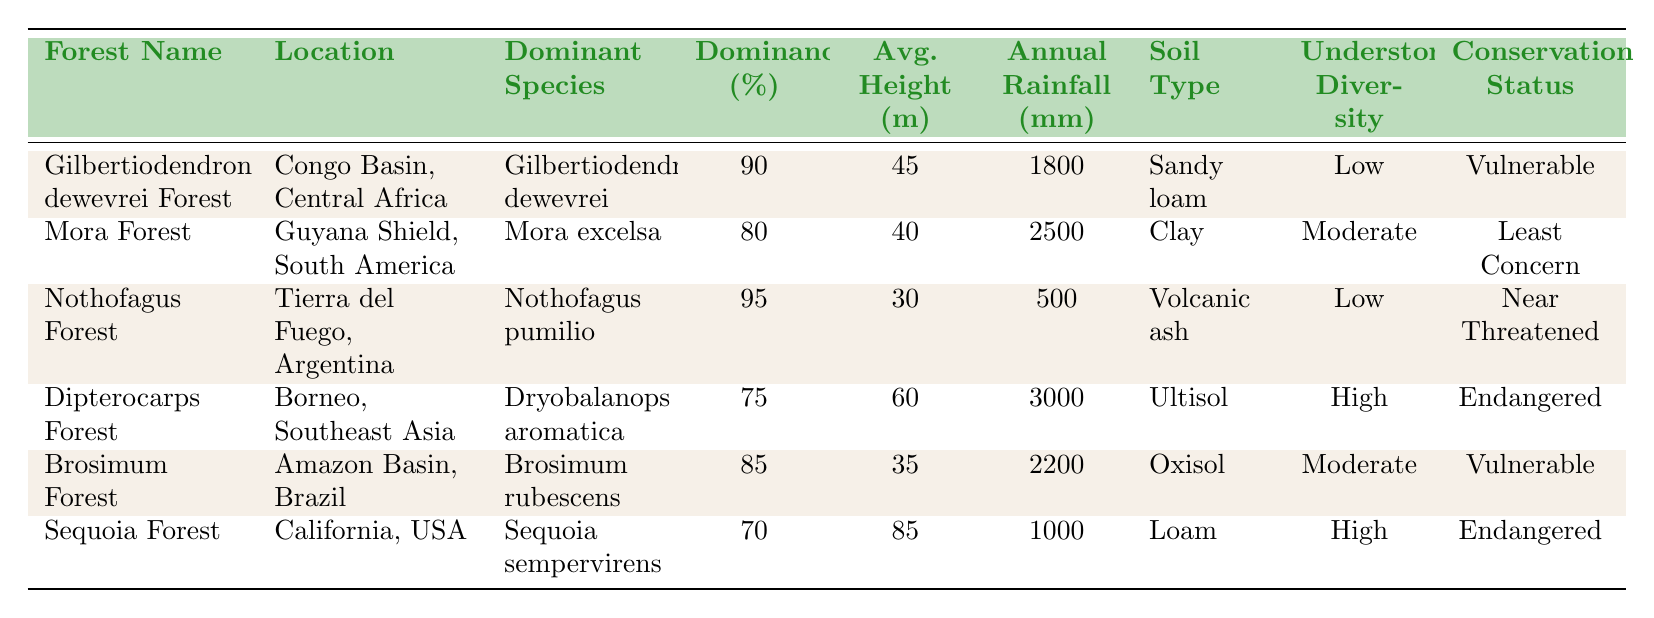What is the dominant species in the Gilbertiodendron dewevrei Forest? The table indicates that the dominant species in the Gilbertiodendron dewevrei Forest is Gilbertiodendron dewevrei.
Answer: Gilbertiodendron dewevrei Which forest has the highest percentage of dominance? By examining the table, Nothofagus Forest has the highest percentage of dominance at 95%.
Answer: Nothofagus Forest What is the average tree height of the Dipterocarps Forest? The Dipterocarps Forest's average tree height is listed in the table as 60 meters.
Answer: 60 meters Is the Nothofagus Forest's conservation status classified as Endangered? No, the conservation status of the Nothofagus Forest is Near Threatened, not Endangered.
Answer: No What is the average annual rainfall of all listed forests? To find the average, we sum the annual rainfalls (1800 + 2500 + 500 + 3000 + 2200 + 1000) = 11000 mm and divide by 6 forests, resulting in an average of 1833.33 mm.
Answer: 1833.33 mm How many forests have an understory diversity classified as High? According to the table, two forests, Dipterocarps Forest and Sequoia Forest, have an understory diversity classified as High.
Answer: 2 What is the soil type of the Mora Forest? The table shows that the soil type of the Mora Forest is Clay.
Answer: Clay Which forest has the lowest annual rainfall, and what is that amount? Upon checking the table, Nothofagus Forest has the lowest annual rainfall at 500 mm.
Answer: Nothofagus Forest; 500 mm What is the difference in average tree height between Gilbertiodendron dewevrei Forest and Brosimum Forest? The average tree height of Gilbertiodendron dewevrei Forest is 45 m and Brosimum Forest is 35 m. The difference is 45 - 35 = 10 m.
Answer: 10 meters Is the conservation status of the Sequoia Forest classified as Least Concern? No, the conservation status of the Sequoia Forest is Endangered, not Least Concern.
Answer: No 